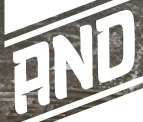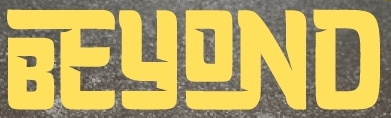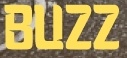Read the text content from these images in order, separated by a semicolon. AND; BEYOND; BUZZ 